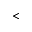<formula> <loc_0><loc_0><loc_500><loc_500><</formula> 